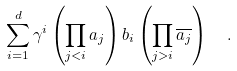<formula> <loc_0><loc_0><loc_500><loc_500>\sum _ { i = 1 } ^ { d } \gamma ^ { i } \left ( \prod _ { j < i } { a _ { j } } \right ) b _ { i } \left ( \prod _ { j > i } \overline { a _ { j } } \right ) \ \ .</formula> 